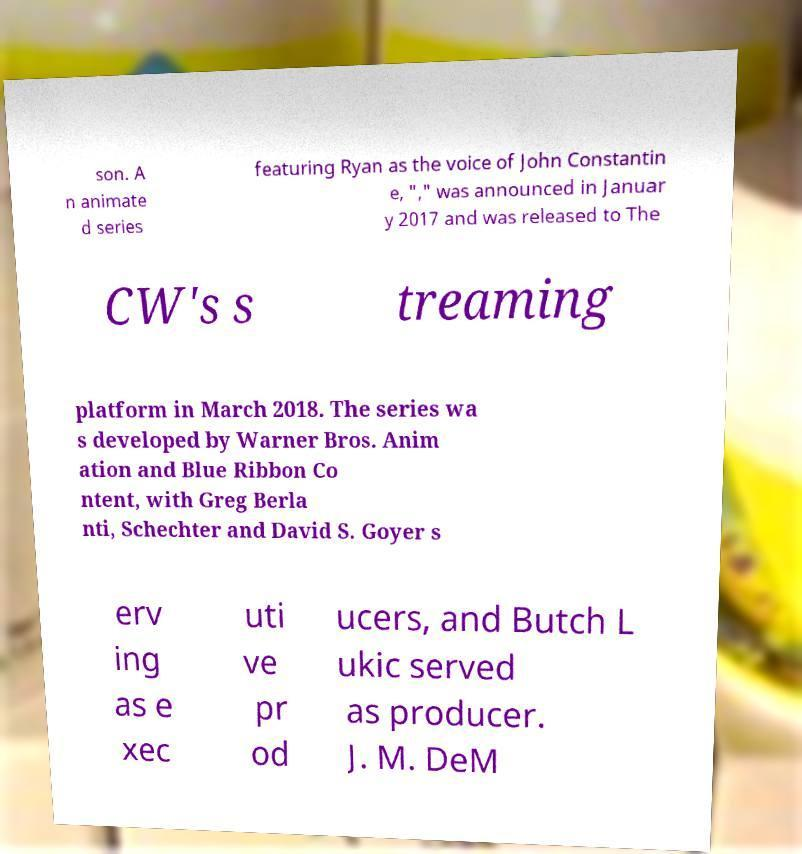Could you assist in decoding the text presented in this image and type it out clearly? son. A n animate d series featuring Ryan as the voice of John Constantin e, "," was announced in Januar y 2017 and was released to The CW's s treaming platform in March 2018. The series wa s developed by Warner Bros. Anim ation and Blue Ribbon Co ntent, with Greg Berla nti, Schechter and David S. Goyer s erv ing as e xec uti ve pr od ucers, and Butch L ukic served as producer. J. M. DeM 